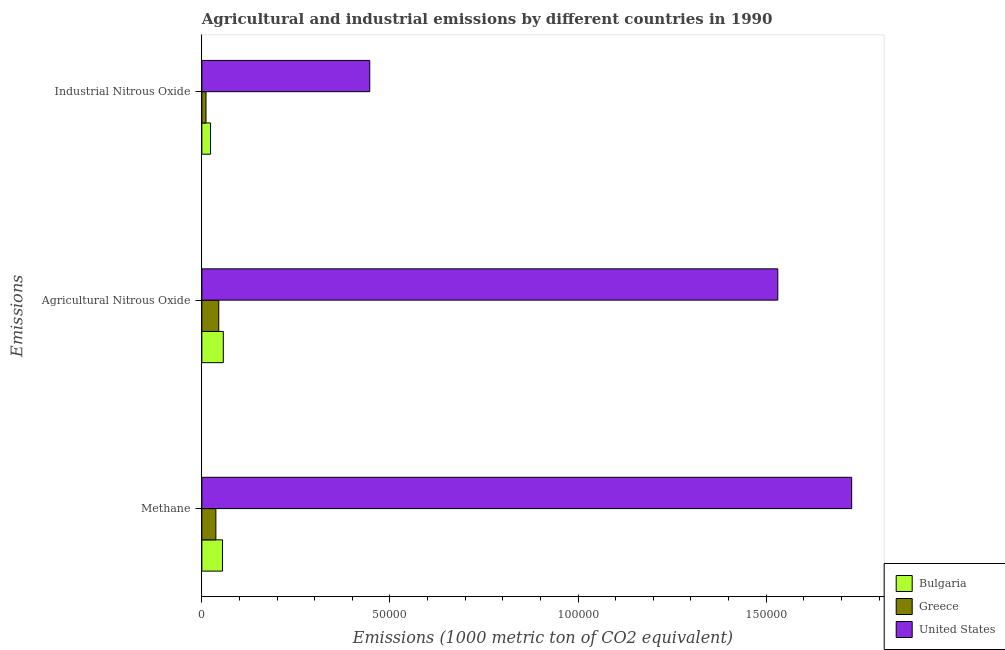How many groups of bars are there?
Your response must be concise. 3. Are the number of bars per tick equal to the number of legend labels?
Offer a terse response. Yes. How many bars are there on the 3rd tick from the top?
Provide a short and direct response. 3. How many bars are there on the 2nd tick from the bottom?
Provide a short and direct response. 3. What is the label of the 3rd group of bars from the top?
Ensure brevity in your answer.  Methane. What is the amount of agricultural nitrous oxide emissions in United States?
Your answer should be very brief. 1.53e+05. Across all countries, what is the maximum amount of industrial nitrous oxide emissions?
Your answer should be very brief. 4.46e+04. Across all countries, what is the minimum amount of methane emissions?
Provide a short and direct response. 3728.5. What is the total amount of methane emissions in the graph?
Make the answer very short. 1.82e+05. What is the difference between the amount of agricultural nitrous oxide emissions in United States and that in Greece?
Your answer should be compact. 1.49e+05. What is the difference between the amount of agricultural nitrous oxide emissions in United States and the amount of industrial nitrous oxide emissions in Greece?
Make the answer very short. 1.52e+05. What is the average amount of industrial nitrous oxide emissions per country?
Offer a very short reply. 1.60e+04. What is the difference between the amount of agricultural nitrous oxide emissions and amount of industrial nitrous oxide emissions in United States?
Offer a terse response. 1.08e+05. In how many countries, is the amount of methane emissions greater than 10000 metric ton?
Your answer should be compact. 1. What is the ratio of the amount of methane emissions in Greece to that in Bulgaria?
Give a very brief answer. 0.68. What is the difference between the highest and the second highest amount of methane emissions?
Provide a short and direct response. 1.67e+05. What is the difference between the highest and the lowest amount of agricultural nitrous oxide emissions?
Keep it short and to the point. 1.49e+05. Is the sum of the amount of methane emissions in Greece and United States greater than the maximum amount of industrial nitrous oxide emissions across all countries?
Your response must be concise. Yes. What does the 2nd bar from the top in Methane represents?
Provide a short and direct response. Greece. Is it the case that in every country, the sum of the amount of methane emissions and amount of agricultural nitrous oxide emissions is greater than the amount of industrial nitrous oxide emissions?
Your answer should be compact. Yes. Are all the bars in the graph horizontal?
Offer a terse response. Yes. What is the difference between two consecutive major ticks on the X-axis?
Offer a terse response. 5.00e+04. Are the values on the major ticks of X-axis written in scientific E-notation?
Keep it short and to the point. No. Does the graph contain any zero values?
Your response must be concise. No. What is the title of the graph?
Keep it short and to the point. Agricultural and industrial emissions by different countries in 1990. Does "Saudi Arabia" appear as one of the legend labels in the graph?
Your answer should be very brief. No. What is the label or title of the X-axis?
Offer a terse response. Emissions (1000 metric ton of CO2 equivalent). What is the label or title of the Y-axis?
Make the answer very short. Emissions. What is the Emissions (1000 metric ton of CO2 equivalent) of Bulgaria in Methane?
Your answer should be compact. 5498.3. What is the Emissions (1000 metric ton of CO2 equivalent) in Greece in Methane?
Ensure brevity in your answer.  3728.5. What is the Emissions (1000 metric ton of CO2 equivalent) in United States in Methane?
Your answer should be compact. 1.73e+05. What is the Emissions (1000 metric ton of CO2 equivalent) of Bulgaria in Agricultural Nitrous Oxide?
Make the answer very short. 5705.4. What is the Emissions (1000 metric ton of CO2 equivalent) of Greece in Agricultural Nitrous Oxide?
Ensure brevity in your answer.  4492.8. What is the Emissions (1000 metric ton of CO2 equivalent) of United States in Agricultural Nitrous Oxide?
Offer a very short reply. 1.53e+05. What is the Emissions (1000 metric ton of CO2 equivalent) of Bulgaria in Industrial Nitrous Oxide?
Your answer should be compact. 2311.2. What is the Emissions (1000 metric ton of CO2 equivalent) in Greece in Industrial Nitrous Oxide?
Your answer should be very brief. 1109.1. What is the Emissions (1000 metric ton of CO2 equivalent) of United States in Industrial Nitrous Oxide?
Offer a terse response. 4.46e+04. Across all Emissions, what is the maximum Emissions (1000 metric ton of CO2 equivalent) in Bulgaria?
Keep it short and to the point. 5705.4. Across all Emissions, what is the maximum Emissions (1000 metric ton of CO2 equivalent) in Greece?
Offer a terse response. 4492.8. Across all Emissions, what is the maximum Emissions (1000 metric ton of CO2 equivalent) of United States?
Make the answer very short. 1.73e+05. Across all Emissions, what is the minimum Emissions (1000 metric ton of CO2 equivalent) of Bulgaria?
Your response must be concise. 2311.2. Across all Emissions, what is the minimum Emissions (1000 metric ton of CO2 equivalent) in Greece?
Your response must be concise. 1109.1. Across all Emissions, what is the minimum Emissions (1000 metric ton of CO2 equivalent) in United States?
Ensure brevity in your answer.  4.46e+04. What is the total Emissions (1000 metric ton of CO2 equivalent) in Bulgaria in the graph?
Provide a succinct answer. 1.35e+04. What is the total Emissions (1000 metric ton of CO2 equivalent) in Greece in the graph?
Provide a short and direct response. 9330.4. What is the total Emissions (1000 metric ton of CO2 equivalent) in United States in the graph?
Your response must be concise. 3.70e+05. What is the difference between the Emissions (1000 metric ton of CO2 equivalent) in Bulgaria in Methane and that in Agricultural Nitrous Oxide?
Keep it short and to the point. -207.1. What is the difference between the Emissions (1000 metric ton of CO2 equivalent) in Greece in Methane and that in Agricultural Nitrous Oxide?
Keep it short and to the point. -764.3. What is the difference between the Emissions (1000 metric ton of CO2 equivalent) of United States in Methane and that in Agricultural Nitrous Oxide?
Make the answer very short. 1.96e+04. What is the difference between the Emissions (1000 metric ton of CO2 equivalent) in Bulgaria in Methane and that in Industrial Nitrous Oxide?
Keep it short and to the point. 3187.1. What is the difference between the Emissions (1000 metric ton of CO2 equivalent) in Greece in Methane and that in Industrial Nitrous Oxide?
Ensure brevity in your answer.  2619.4. What is the difference between the Emissions (1000 metric ton of CO2 equivalent) of United States in Methane and that in Industrial Nitrous Oxide?
Offer a terse response. 1.28e+05. What is the difference between the Emissions (1000 metric ton of CO2 equivalent) in Bulgaria in Agricultural Nitrous Oxide and that in Industrial Nitrous Oxide?
Offer a terse response. 3394.2. What is the difference between the Emissions (1000 metric ton of CO2 equivalent) in Greece in Agricultural Nitrous Oxide and that in Industrial Nitrous Oxide?
Provide a short and direct response. 3383.7. What is the difference between the Emissions (1000 metric ton of CO2 equivalent) of United States in Agricultural Nitrous Oxide and that in Industrial Nitrous Oxide?
Provide a succinct answer. 1.08e+05. What is the difference between the Emissions (1000 metric ton of CO2 equivalent) of Bulgaria in Methane and the Emissions (1000 metric ton of CO2 equivalent) of Greece in Agricultural Nitrous Oxide?
Provide a succinct answer. 1005.5. What is the difference between the Emissions (1000 metric ton of CO2 equivalent) of Bulgaria in Methane and the Emissions (1000 metric ton of CO2 equivalent) of United States in Agricultural Nitrous Oxide?
Keep it short and to the point. -1.48e+05. What is the difference between the Emissions (1000 metric ton of CO2 equivalent) of Greece in Methane and the Emissions (1000 metric ton of CO2 equivalent) of United States in Agricultural Nitrous Oxide?
Keep it short and to the point. -1.49e+05. What is the difference between the Emissions (1000 metric ton of CO2 equivalent) of Bulgaria in Methane and the Emissions (1000 metric ton of CO2 equivalent) of Greece in Industrial Nitrous Oxide?
Offer a very short reply. 4389.2. What is the difference between the Emissions (1000 metric ton of CO2 equivalent) in Bulgaria in Methane and the Emissions (1000 metric ton of CO2 equivalent) in United States in Industrial Nitrous Oxide?
Your answer should be very brief. -3.91e+04. What is the difference between the Emissions (1000 metric ton of CO2 equivalent) of Greece in Methane and the Emissions (1000 metric ton of CO2 equivalent) of United States in Industrial Nitrous Oxide?
Your response must be concise. -4.09e+04. What is the difference between the Emissions (1000 metric ton of CO2 equivalent) of Bulgaria in Agricultural Nitrous Oxide and the Emissions (1000 metric ton of CO2 equivalent) of Greece in Industrial Nitrous Oxide?
Keep it short and to the point. 4596.3. What is the difference between the Emissions (1000 metric ton of CO2 equivalent) of Bulgaria in Agricultural Nitrous Oxide and the Emissions (1000 metric ton of CO2 equivalent) of United States in Industrial Nitrous Oxide?
Keep it short and to the point. -3.89e+04. What is the difference between the Emissions (1000 metric ton of CO2 equivalent) in Greece in Agricultural Nitrous Oxide and the Emissions (1000 metric ton of CO2 equivalent) in United States in Industrial Nitrous Oxide?
Offer a terse response. -4.01e+04. What is the average Emissions (1000 metric ton of CO2 equivalent) of Bulgaria per Emissions?
Your answer should be very brief. 4504.97. What is the average Emissions (1000 metric ton of CO2 equivalent) in Greece per Emissions?
Your answer should be very brief. 3110.13. What is the average Emissions (1000 metric ton of CO2 equivalent) in United States per Emissions?
Give a very brief answer. 1.23e+05. What is the difference between the Emissions (1000 metric ton of CO2 equivalent) of Bulgaria and Emissions (1000 metric ton of CO2 equivalent) of Greece in Methane?
Your answer should be very brief. 1769.8. What is the difference between the Emissions (1000 metric ton of CO2 equivalent) of Bulgaria and Emissions (1000 metric ton of CO2 equivalent) of United States in Methane?
Your answer should be very brief. -1.67e+05. What is the difference between the Emissions (1000 metric ton of CO2 equivalent) in Greece and Emissions (1000 metric ton of CO2 equivalent) in United States in Methane?
Ensure brevity in your answer.  -1.69e+05. What is the difference between the Emissions (1000 metric ton of CO2 equivalent) of Bulgaria and Emissions (1000 metric ton of CO2 equivalent) of Greece in Agricultural Nitrous Oxide?
Your response must be concise. 1212.6. What is the difference between the Emissions (1000 metric ton of CO2 equivalent) in Bulgaria and Emissions (1000 metric ton of CO2 equivalent) in United States in Agricultural Nitrous Oxide?
Keep it short and to the point. -1.47e+05. What is the difference between the Emissions (1000 metric ton of CO2 equivalent) of Greece and Emissions (1000 metric ton of CO2 equivalent) of United States in Agricultural Nitrous Oxide?
Ensure brevity in your answer.  -1.49e+05. What is the difference between the Emissions (1000 metric ton of CO2 equivalent) of Bulgaria and Emissions (1000 metric ton of CO2 equivalent) of Greece in Industrial Nitrous Oxide?
Offer a very short reply. 1202.1. What is the difference between the Emissions (1000 metric ton of CO2 equivalent) of Bulgaria and Emissions (1000 metric ton of CO2 equivalent) of United States in Industrial Nitrous Oxide?
Offer a terse response. -4.23e+04. What is the difference between the Emissions (1000 metric ton of CO2 equivalent) in Greece and Emissions (1000 metric ton of CO2 equivalent) in United States in Industrial Nitrous Oxide?
Your answer should be very brief. -4.35e+04. What is the ratio of the Emissions (1000 metric ton of CO2 equivalent) of Bulgaria in Methane to that in Agricultural Nitrous Oxide?
Offer a very short reply. 0.96. What is the ratio of the Emissions (1000 metric ton of CO2 equivalent) of Greece in Methane to that in Agricultural Nitrous Oxide?
Your answer should be compact. 0.83. What is the ratio of the Emissions (1000 metric ton of CO2 equivalent) in United States in Methane to that in Agricultural Nitrous Oxide?
Ensure brevity in your answer.  1.13. What is the ratio of the Emissions (1000 metric ton of CO2 equivalent) in Bulgaria in Methane to that in Industrial Nitrous Oxide?
Keep it short and to the point. 2.38. What is the ratio of the Emissions (1000 metric ton of CO2 equivalent) in Greece in Methane to that in Industrial Nitrous Oxide?
Your response must be concise. 3.36. What is the ratio of the Emissions (1000 metric ton of CO2 equivalent) in United States in Methane to that in Industrial Nitrous Oxide?
Your answer should be compact. 3.87. What is the ratio of the Emissions (1000 metric ton of CO2 equivalent) of Bulgaria in Agricultural Nitrous Oxide to that in Industrial Nitrous Oxide?
Offer a very short reply. 2.47. What is the ratio of the Emissions (1000 metric ton of CO2 equivalent) of Greece in Agricultural Nitrous Oxide to that in Industrial Nitrous Oxide?
Offer a terse response. 4.05. What is the ratio of the Emissions (1000 metric ton of CO2 equivalent) of United States in Agricultural Nitrous Oxide to that in Industrial Nitrous Oxide?
Ensure brevity in your answer.  3.43. What is the difference between the highest and the second highest Emissions (1000 metric ton of CO2 equivalent) of Bulgaria?
Keep it short and to the point. 207.1. What is the difference between the highest and the second highest Emissions (1000 metric ton of CO2 equivalent) in Greece?
Make the answer very short. 764.3. What is the difference between the highest and the second highest Emissions (1000 metric ton of CO2 equivalent) in United States?
Make the answer very short. 1.96e+04. What is the difference between the highest and the lowest Emissions (1000 metric ton of CO2 equivalent) in Bulgaria?
Offer a terse response. 3394.2. What is the difference between the highest and the lowest Emissions (1000 metric ton of CO2 equivalent) of Greece?
Offer a terse response. 3383.7. What is the difference between the highest and the lowest Emissions (1000 metric ton of CO2 equivalent) in United States?
Keep it short and to the point. 1.28e+05. 